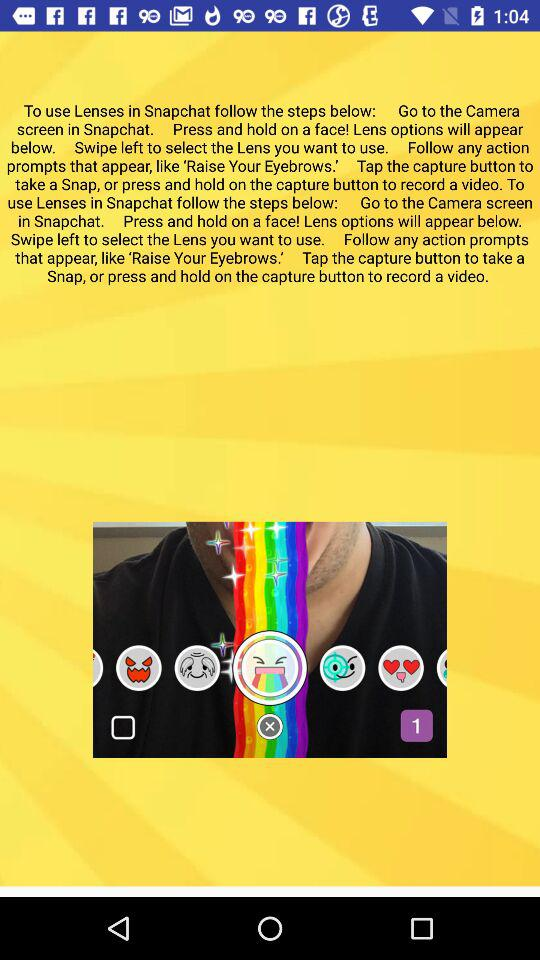Who is the user?
When the provided information is insufficient, respond with <no answer>. <no answer> 